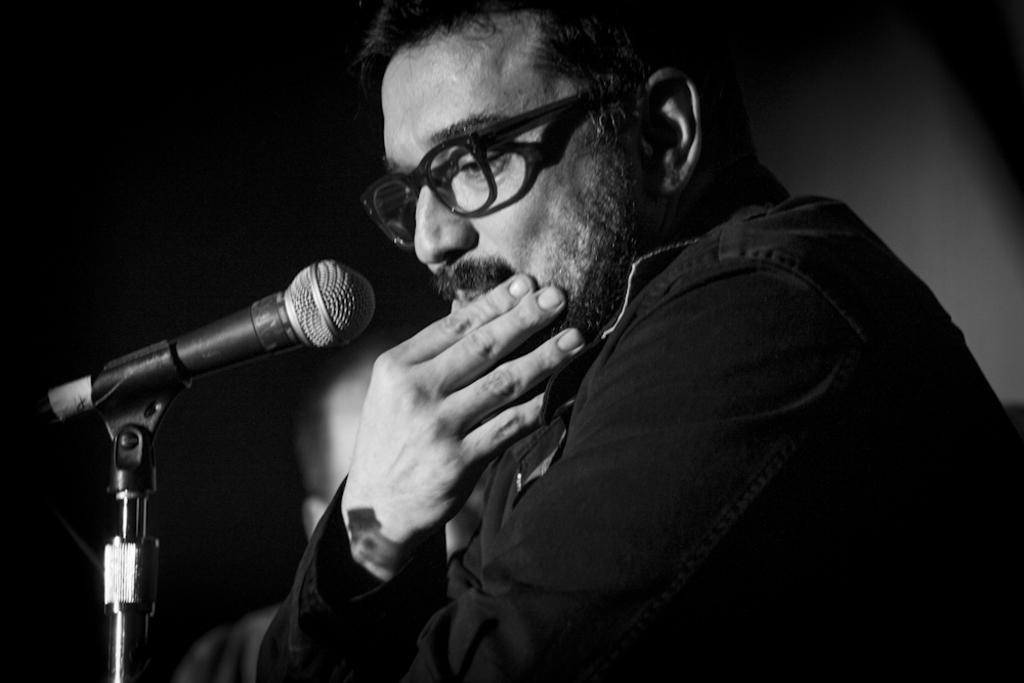Describe this image in one or two sentences. In this image there are two persons are in middle of this image and there is one Mic at left side of this image. 